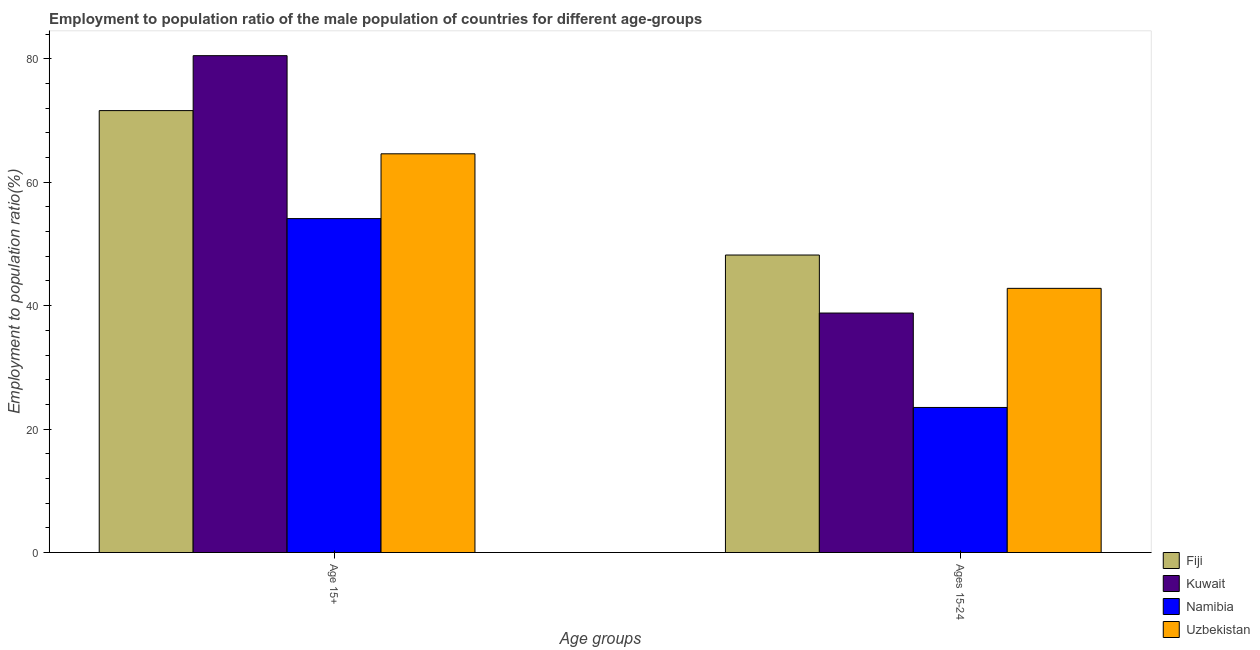Are the number of bars on each tick of the X-axis equal?
Ensure brevity in your answer.  Yes. How many bars are there on the 2nd tick from the left?
Give a very brief answer. 4. What is the label of the 2nd group of bars from the left?
Offer a terse response. Ages 15-24. What is the employment to population ratio(age 15-24) in Fiji?
Ensure brevity in your answer.  48.2. Across all countries, what is the maximum employment to population ratio(age 15-24)?
Provide a short and direct response. 48.2. Across all countries, what is the minimum employment to population ratio(age 15+)?
Give a very brief answer. 54.1. In which country was the employment to population ratio(age 15+) maximum?
Keep it short and to the point. Kuwait. In which country was the employment to population ratio(age 15+) minimum?
Your answer should be very brief. Namibia. What is the total employment to population ratio(age 15-24) in the graph?
Provide a short and direct response. 153.3. What is the difference between the employment to population ratio(age 15-24) in Uzbekistan and that in Kuwait?
Your answer should be compact. 4. What is the difference between the employment to population ratio(age 15+) in Fiji and the employment to population ratio(age 15-24) in Kuwait?
Keep it short and to the point. 32.8. What is the average employment to population ratio(age 15+) per country?
Ensure brevity in your answer.  67.7. What is the difference between the employment to population ratio(age 15-24) and employment to population ratio(age 15+) in Uzbekistan?
Make the answer very short. -21.8. What is the ratio of the employment to population ratio(age 15-24) in Namibia to that in Fiji?
Give a very brief answer. 0.49. In how many countries, is the employment to population ratio(age 15-24) greater than the average employment to population ratio(age 15-24) taken over all countries?
Offer a very short reply. 3. What does the 2nd bar from the left in Age 15+ represents?
Your answer should be compact. Kuwait. What does the 3rd bar from the right in Ages 15-24 represents?
Make the answer very short. Kuwait. How many bars are there?
Give a very brief answer. 8. Are the values on the major ticks of Y-axis written in scientific E-notation?
Give a very brief answer. No. Where does the legend appear in the graph?
Provide a short and direct response. Bottom right. How many legend labels are there?
Make the answer very short. 4. What is the title of the graph?
Provide a short and direct response. Employment to population ratio of the male population of countries for different age-groups. Does "Syrian Arab Republic" appear as one of the legend labels in the graph?
Your answer should be very brief. No. What is the label or title of the X-axis?
Make the answer very short. Age groups. What is the Employment to population ratio(%) in Fiji in Age 15+?
Your answer should be compact. 71.6. What is the Employment to population ratio(%) of Kuwait in Age 15+?
Your answer should be compact. 80.5. What is the Employment to population ratio(%) in Namibia in Age 15+?
Offer a very short reply. 54.1. What is the Employment to population ratio(%) of Uzbekistan in Age 15+?
Your response must be concise. 64.6. What is the Employment to population ratio(%) in Fiji in Ages 15-24?
Your answer should be compact. 48.2. What is the Employment to population ratio(%) in Kuwait in Ages 15-24?
Your answer should be very brief. 38.8. What is the Employment to population ratio(%) of Uzbekistan in Ages 15-24?
Offer a very short reply. 42.8. Across all Age groups, what is the maximum Employment to population ratio(%) of Fiji?
Your answer should be compact. 71.6. Across all Age groups, what is the maximum Employment to population ratio(%) in Kuwait?
Provide a short and direct response. 80.5. Across all Age groups, what is the maximum Employment to population ratio(%) of Namibia?
Offer a very short reply. 54.1. Across all Age groups, what is the maximum Employment to population ratio(%) in Uzbekistan?
Provide a succinct answer. 64.6. Across all Age groups, what is the minimum Employment to population ratio(%) in Fiji?
Offer a very short reply. 48.2. Across all Age groups, what is the minimum Employment to population ratio(%) of Kuwait?
Offer a terse response. 38.8. Across all Age groups, what is the minimum Employment to population ratio(%) in Namibia?
Provide a short and direct response. 23.5. Across all Age groups, what is the minimum Employment to population ratio(%) of Uzbekistan?
Your response must be concise. 42.8. What is the total Employment to population ratio(%) in Fiji in the graph?
Your response must be concise. 119.8. What is the total Employment to population ratio(%) in Kuwait in the graph?
Offer a very short reply. 119.3. What is the total Employment to population ratio(%) of Namibia in the graph?
Your answer should be very brief. 77.6. What is the total Employment to population ratio(%) of Uzbekistan in the graph?
Provide a short and direct response. 107.4. What is the difference between the Employment to population ratio(%) of Fiji in Age 15+ and that in Ages 15-24?
Ensure brevity in your answer.  23.4. What is the difference between the Employment to population ratio(%) of Kuwait in Age 15+ and that in Ages 15-24?
Make the answer very short. 41.7. What is the difference between the Employment to population ratio(%) of Namibia in Age 15+ and that in Ages 15-24?
Offer a very short reply. 30.6. What is the difference between the Employment to population ratio(%) in Uzbekistan in Age 15+ and that in Ages 15-24?
Your answer should be very brief. 21.8. What is the difference between the Employment to population ratio(%) in Fiji in Age 15+ and the Employment to population ratio(%) in Kuwait in Ages 15-24?
Provide a short and direct response. 32.8. What is the difference between the Employment to population ratio(%) of Fiji in Age 15+ and the Employment to population ratio(%) of Namibia in Ages 15-24?
Offer a very short reply. 48.1. What is the difference between the Employment to population ratio(%) in Fiji in Age 15+ and the Employment to population ratio(%) in Uzbekistan in Ages 15-24?
Offer a terse response. 28.8. What is the difference between the Employment to population ratio(%) of Kuwait in Age 15+ and the Employment to population ratio(%) of Uzbekistan in Ages 15-24?
Your response must be concise. 37.7. What is the difference between the Employment to population ratio(%) of Namibia in Age 15+ and the Employment to population ratio(%) of Uzbekistan in Ages 15-24?
Keep it short and to the point. 11.3. What is the average Employment to population ratio(%) of Fiji per Age groups?
Offer a terse response. 59.9. What is the average Employment to population ratio(%) of Kuwait per Age groups?
Keep it short and to the point. 59.65. What is the average Employment to population ratio(%) in Namibia per Age groups?
Offer a terse response. 38.8. What is the average Employment to population ratio(%) in Uzbekistan per Age groups?
Your answer should be compact. 53.7. What is the difference between the Employment to population ratio(%) in Fiji and Employment to population ratio(%) in Uzbekistan in Age 15+?
Offer a very short reply. 7. What is the difference between the Employment to population ratio(%) in Kuwait and Employment to population ratio(%) in Namibia in Age 15+?
Give a very brief answer. 26.4. What is the difference between the Employment to population ratio(%) in Kuwait and Employment to population ratio(%) in Uzbekistan in Age 15+?
Ensure brevity in your answer.  15.9. What is the difference between the Employment to population ratio(%) in Namibia and Employment to population ratio(%) in Uzbekistan in Age 15+?
Your answer should be very brief. -10.5. What is the difference between the Employment to population ratio(%) of Fiji and Employment to population ratio(%) of Namibia in Ages 15-24?
Provide a short and direct response. 24.7. What is the difference between the Employment to population ratio(%) of Fiji and Employment to population ratio(%) of Uzbekistan in Ages 15-24?
Your answer should be compact. 5.4. What is the difference between the Employment to population ratio(%) in Kuwait and Employment to population ratio(%) in Namibia in Ages 15-24?
Keep it short and to the point. 15.3. What is the difference between the Employment to population ratio(%) of Namibia and Employment to population ratio(%) of Uzbekistan in Ages 15-24?
Provide a short and direct response. -19.3. What is the ratio of the Employment to population ratio(%) of Fiji in Age 15+ to that in Ages 15-24?
Keep it short and to the point. 1.49. What is the ratio of the Employment to population ratio(%) of Kuwait in Age 15+ to that in Ages 15-24?
Provide a short and direct response. 2.07. What is the ratio of the Employment to population ratio(%) in Namibia in Age 15+ to that in Ages 15-24?
Your response must be concise. 2.3. What is the ratio of the Employment to population ratio(%) in Uzbekistan in Age 15+ to that in Ages 15-24?
Keep it short and to the point. 1.51. What is the difference between the highest and the second highest Employment to population ratio(%) in Fiji?
Offer a very short reply. 23.4. What is the difference between the highest and the second highest Employment to population ratio(%) of Kuwait?
Your answer should be very brief. 41.7. What is the difference between the highest and the second highest Employment to population ratio(%) in Namibia?
Make the answer very short. 30.6. What is the difference between the highest and the second highest Employment to population ratio(%) of Uzbekistan?
Your answer should be very brief. 21.8. What is the difference between the highest and the lowest Employment to population ratio(%) in Fiji?
Ensure brevity in your answer.  23.4. What is the difference between the highest and the lowest Employment to population ratio(%) of Kuwait?
Provide a short and direct response. 41.7. What is the difference between the highest and the lowest Employment to population ratio(%) of Namibia?
Your response must be concise. 30.6. What is the difference between the highest and the lowest Employment to population ratio(%) in Uzbekistan?
Offer a very short reply. 21.8. 